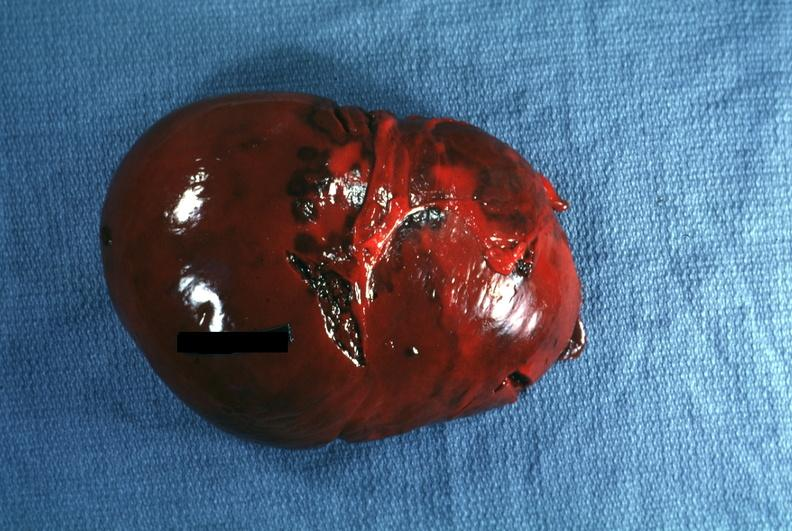s this photo of infant from head to toe present?
Answer the question using a single word or phrase. No 